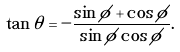Convert formula to latex. <formula><loc_0><loc_0><loc_500><loc_500>\tan \theta = - \frac { \sin \phi + \cos \phi } { \sin \phi \cos \phi } .</formula> 